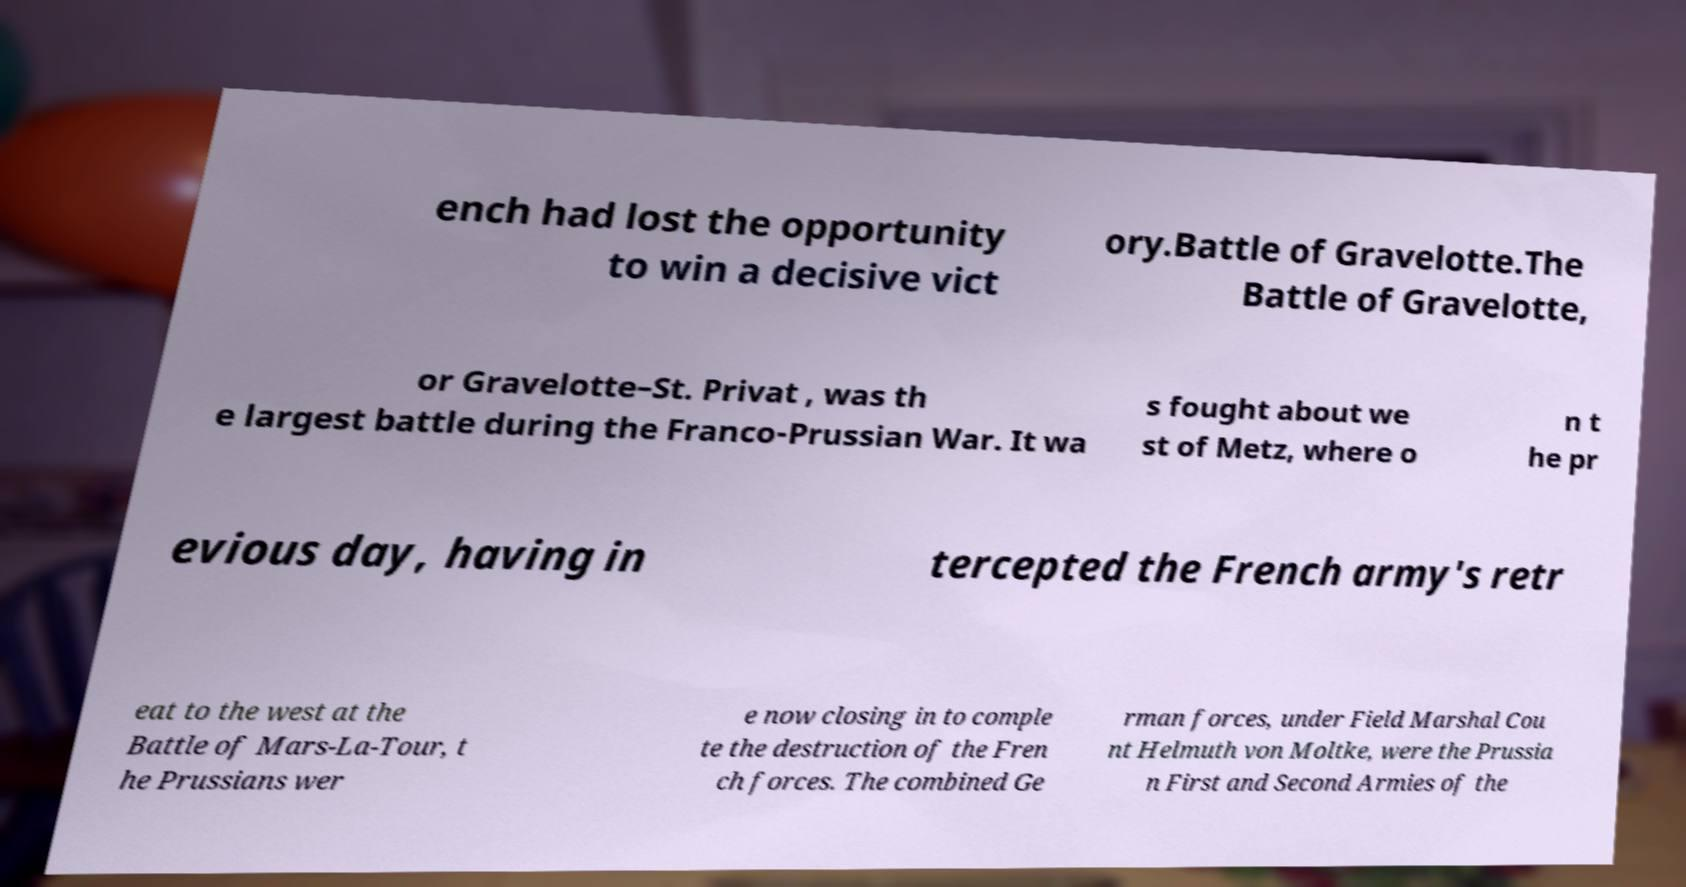Could you assist in decoding the text presented in this image and type it out clearly? ench had lost the opportunity to win a decisive vict ory.Battle of Gravelotte.The Battle of Gravelotte, or Gravelotte–St. Privat , was th e largest battle during the Franco-Prussian War. It wa s fought about we st of Metz, where o n t he pr evious day, having in tercepted the French army's retr eat to the west at the Battle of Mars-La-Tour, t he Prussians wer e now closing in to comple te the destruction of the Fren ch forces. The combined Ge rman forces, under Field Marshal Cou nt Helmuth von Moltke, were the Prussia n First and Second Armies of the 